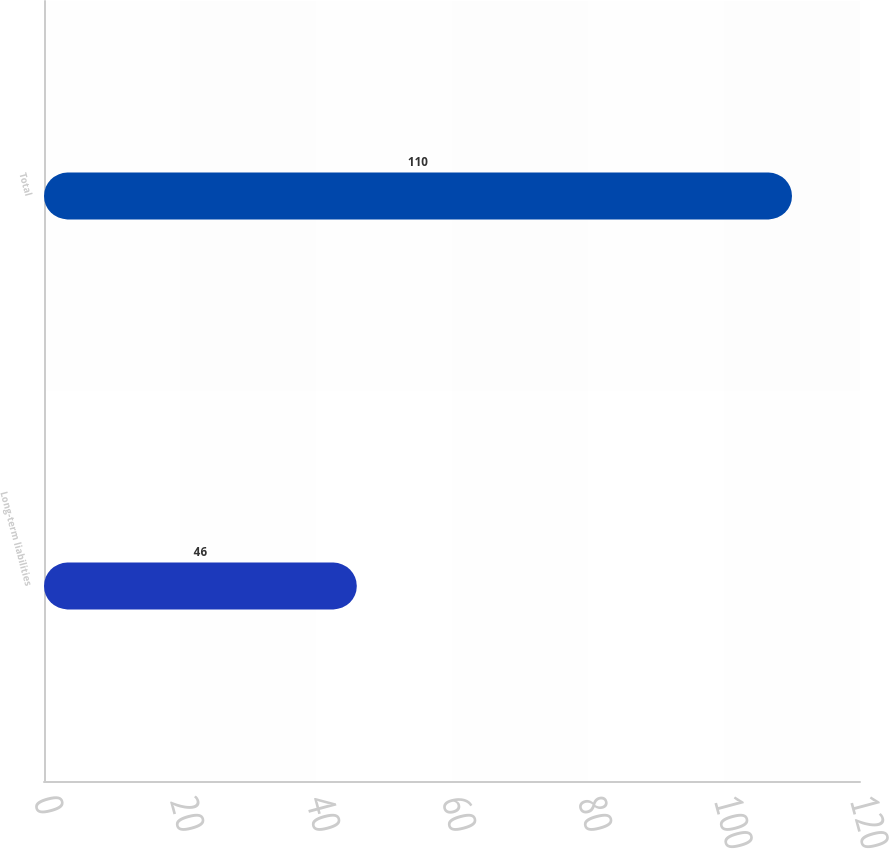Convert chart. <chart><loc_0><loc_0><loc_500><loc_500><bar_chart><fcel>Long-term liabilities<fcel>Total<nl><fcel>46<fcel>110<nl></chart> 